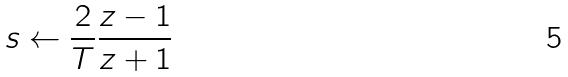<formula> <loc_0><loc_0><loc_500><loc_500>s \leftarrow \frac { 2 } { T } \frac { z - 1 } { z + 1 }</formula> 